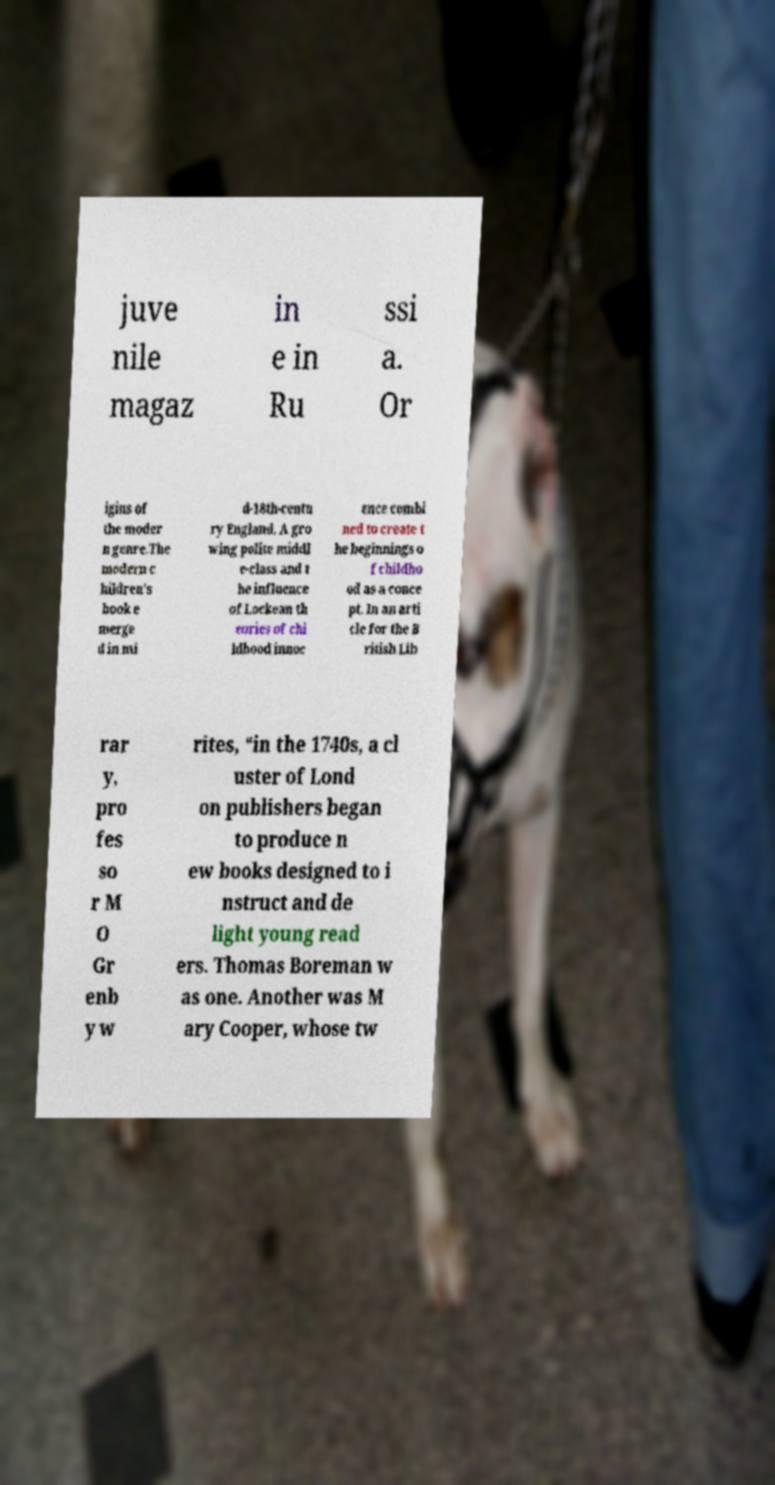Could you extract and type out the text from this image? juve nile magaz in e in Ru ssi a. Or igins of the moder n genre.The modern c hildren's book e merge d in mi d-18th-centu ry England. A gro wing polite middl e-class and t he influence of Lockean th eories of chi ldhood innoc ence combi ned to create t he beginnings o f childho od as a conce pt. In an arti cle for the B ritish Lib rar y, pro fes so r M O Gr enb y w rites, “in the 1740s, a cl uster of Lond on publishers began to produce n ew books designed to i nstruct and de light young read ers. Thomas Boreman w as one. Another was M ary Cooper, whose tw 